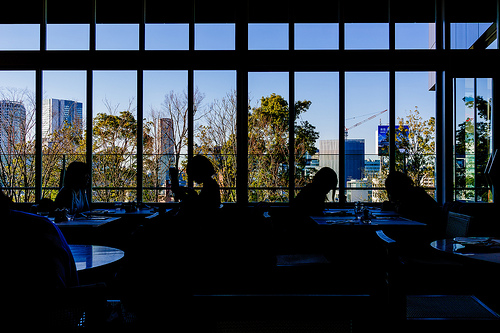<image>
Is the tree behind the person? Yes. From this viewpoint, the tree is positioned behind the person, with the person partially or fully occluding the tree. 